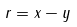<formula> <loc_0><loc_0><loc_500><loc_500>r = x - y</formula> 